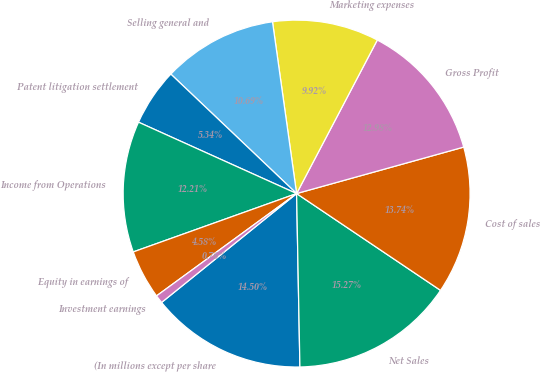Convert chart to OTSL. <chart><loc_0><loc_0><loc_500><loc_500><pie_chart><fcel>(In millions except per share<fcel>Net Sales<fcel>Cost of sales<fcel>Gross Profit<fcel>Marketing expenses<fcel>Selling general and<fcel>Patent litigation settlement<fcel>Income from Operations<fcel>Equity in earnings of<fcel>Investment earnings<nl><fcel>14.5%<fcel>15.27%<fcel>13.74%<fcel>12.98%<fcel>9.92%<fcel>10.69%<fcel>5.34%<fcel>12.21%<fcel>4.58%<fcel>0.76%<nl></chart> 